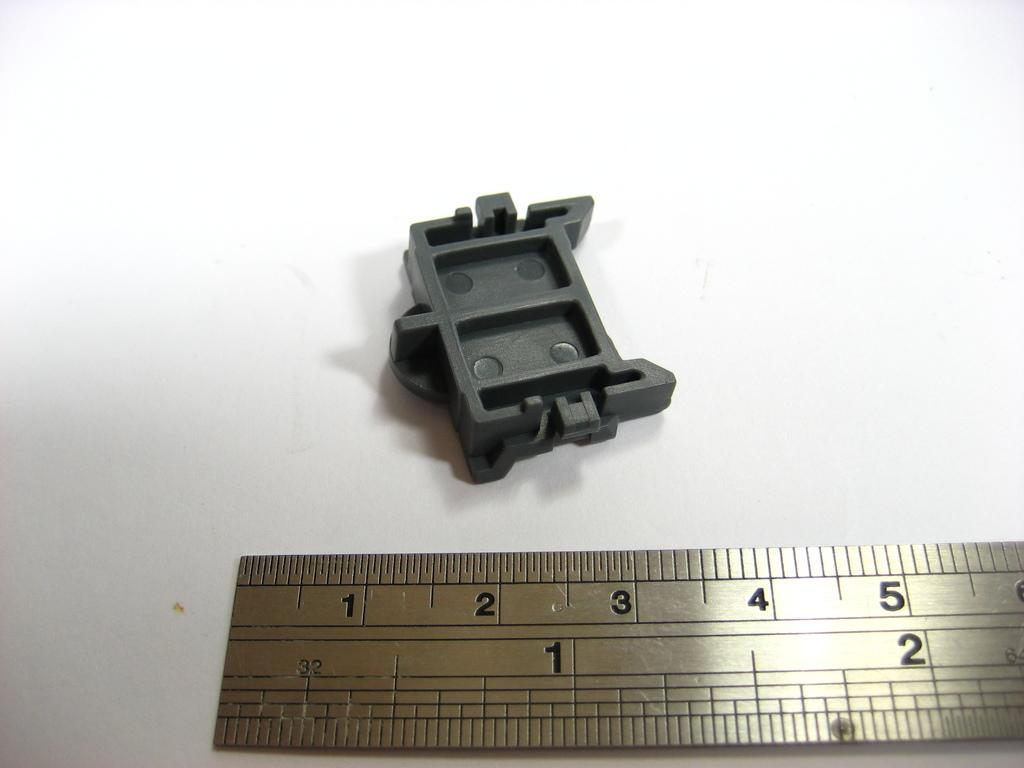<image>
Describe the image concisely. A black plastic part approx 1-1/2" wide laying above a metal ruler. 